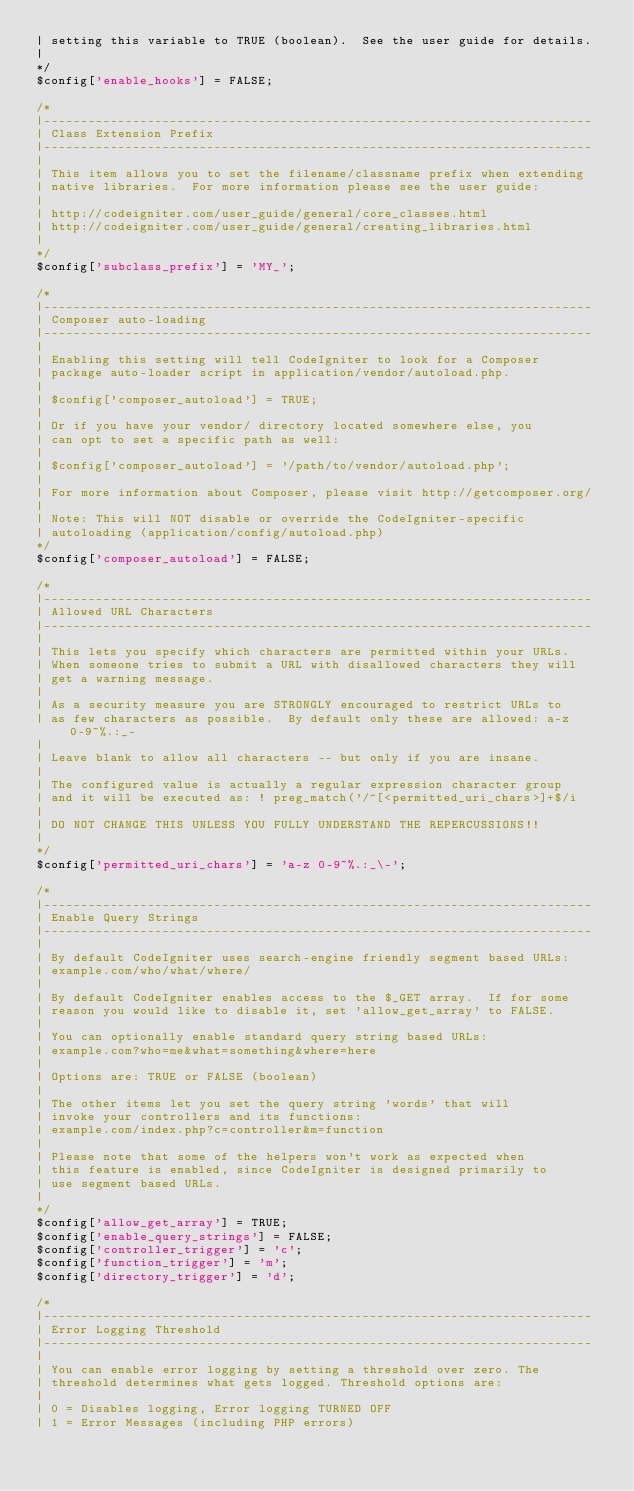<code> <loc_0><loc_0><loc_500><loc_500><_PHP_>| setting this variable to TRUE (boolean).  See the user guide for details.
|
*/
$config['enable_hooks'] = FALSE;

/*
|--------------------------------------------------------------------------
| Class Extension Prefix
|--------------------------------------------------------------------------
|
| This item allows you to set the filename/classname prefix when extending
| native libraries.  For more information please see the user guide:
|
| http://codeigniter.com/user_guide/general/core_classes.html
| http://codeigniter.com/user_guide/general/creating_libraries.html
|
*/
$config['subclass_prefix'] = 'MY_';

/*
|--------------------------------------------------------------------------
| Composer auto-loading
|--------------------------------------------------------------------------
|
| Enabling this setting will tell CodeIgniter to look for a Composer
| package auto-loader script in application/vendor/autoload.php.
|
|	$config['composer_autoload'] = TRUE;
|
| Or if you have your vendor/ directory located somewhere else, you
| can opt to set a specific path as well:
|
|	$config['composer_autoload'] = '/path/to/vendor/autoload.php';
|
| For more information about Composer, please visit http://getcomposer.org/
|
| Note: This will NOT disable or override the CodeIgniter-specific
|	autoloading (application/config/autoload.php)
*/
$config['composer_autoload'] = FALSE;

/*
|--------------------------------------------------------------------------
| Allowed URL Characters
|--------------------------------------------------------------------------
|
| This lets you specify which characters are permitted within your URLs.
| When someone tries to submit a URL with disallowed characters they will
| get a warning message.
|
| As a security measure you are STRONGLY encouraged to restrict URLs to
| as few characters as possible.  By default only these are allowed: a-z 0-9~%.:_-
|
| Leave blank to allow all characters -- but only if you are insane.
|
| The configured value is actually a regular expression character group
| and it will be executed as: ! preg_match('/^[<permitted_uri_chars>]+$/i
|
| DO NOT CHANGE THIS UNLESS YOU FULLY UNDERSTAND THE REPERCUSSIONS!!
|
*/
$config['permitted_uri_chars'] = 'a-z 0-9~%.:_\-';

/*
|--------------------------------------------------------------------------
| Enable Query Strings
|--------------------------------------------------------------------------
|
| By default CodeIgniter uses search-engine friendly segment based URLs:
| example.com/who/what/where/
|
| By default CodeIgniter enables access to the $_GET array.  If for some
| reason you would like to disable it, set 'allow_get_array' to FALSE.
|
| You can optionally enable standard query string based URLs:
| example.com?who=me&what=something&where=here
|
| Options are: TRUE or FALSE (boolean)
|
| The other items let you set the query string 'words' that will
| invoke your controllers and its functions:
| example.com/index.php?c=controller&m=function
|
| Please note that some of the helpers won't work as expected when
| this feature is enabled, since CodeIgniter is designed primarily to
| use segment based URLs.
|
*/
$config['allow_get_array'] = TRUE;
$config['enable_query_strings'] = FALSE;
$config['controller_trigger'] = 'c';
$config['function_trigger'] = 'm';
$config['directory_trigger'] = 'd';

/*
|--------------------------------------------------------------------------
| Error Logging Threshold
|--------------------------------------------------------------------------
|
| You can enable error logging by setting a threshold over zero. The
| threshold determines what gets logged. Threshold options are:
|
|	0 = Disables logging, Error logging TURNED OFF
|	1 = Error Messages (including PHP errors)</code> 